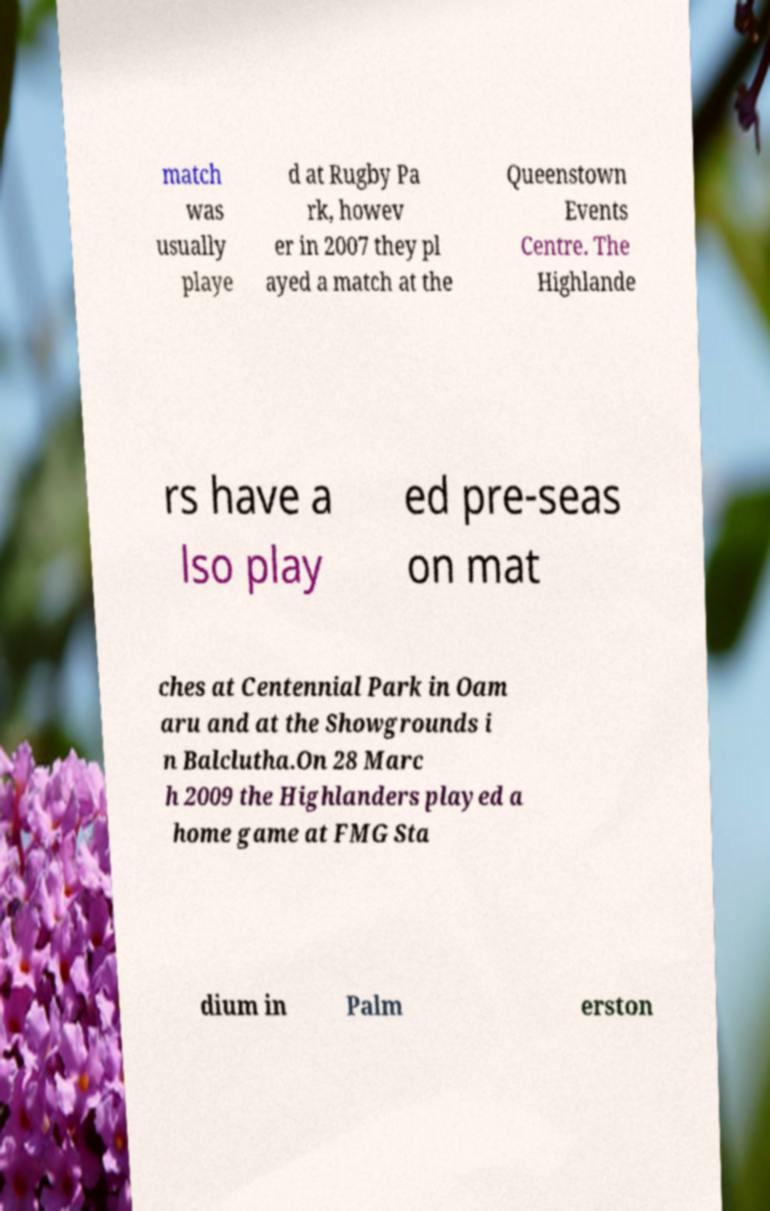Could you extract and type out the text from this image? match was usually playe d at Rugby Pa rk, howev er in 2007 they pl ayed a match at the Queenstown Events Centre. The Highlande rs have a lso play ed pre-seas on mat ches at Centennial Park in Oam aru and at the Showgrounds i n Balclutha.On 28 Marc h 2009 the Highlanders played a home game at FMG Sta dium in Palm erston 